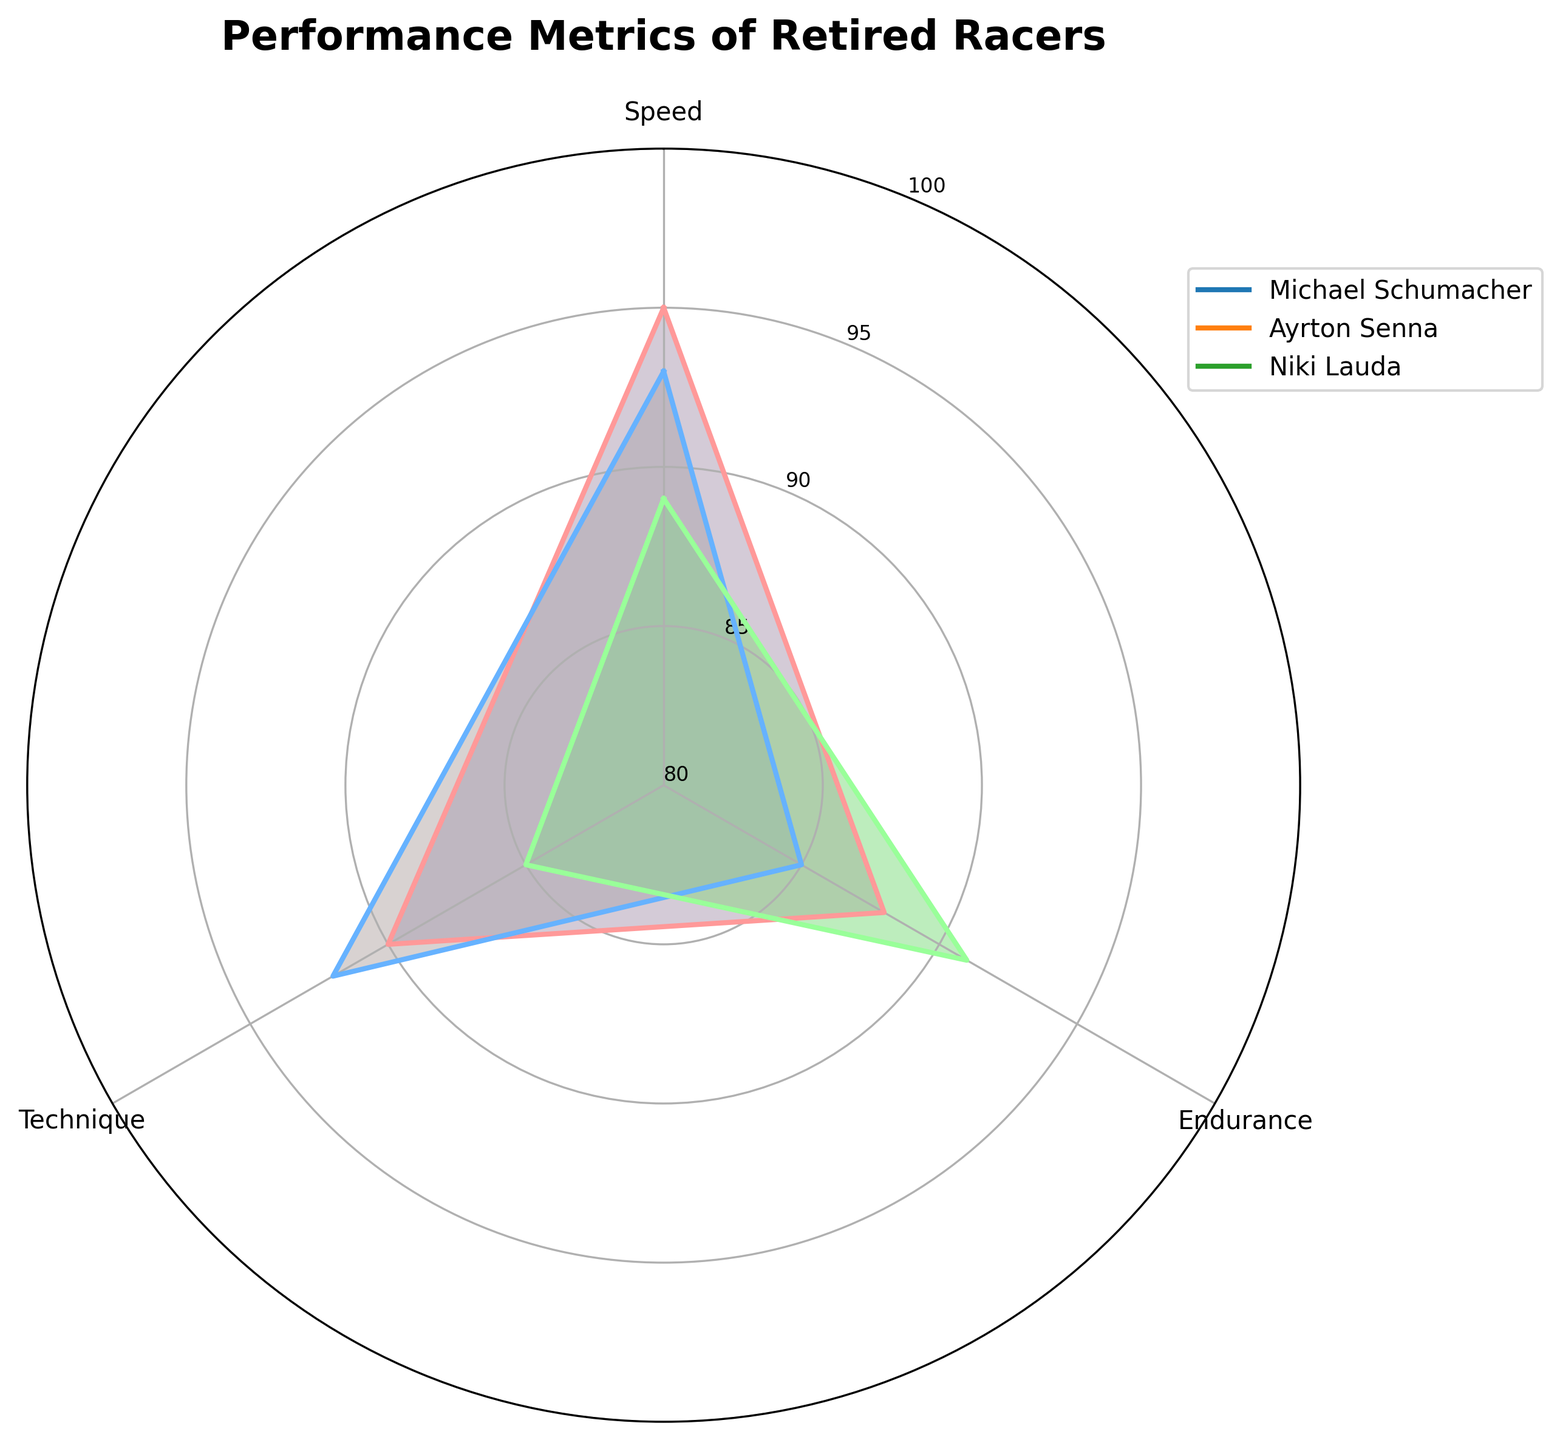What is the title of the figure? The title of the figure is displayed at the top. It provides a summary of what the figure represents. It states, "Performance Metrics of Retired Racers."
Answer: "Performance Metrics of Retired Racers" Which racer has the highest score in speed? By looking at the radar chart, identify the outermost point in the speed category for each racer. The racer with the point furthest from the center has the highest value. Michael Schumacher's point is the furthest in speed.
Answer: Michael Schumacher What is the average Technique score of all the racers? Sum up the Technique scores of all the racers (90 for Schumacher, 92 for Senna, and 85 for Lauda) and divide by the number of racers (3). (90 + 92 + 85) / 3 = 267 / 3 = 89
Answer: 89 Which metric has the largest variation between racers? Look at each metric’s span in the radar chart and find the one with the largest difference between the highest and lowest values. Endurance ranges from 85 (Senna) to 91 (Lauda), making the variation 6, which is the largest among the metrics.
Answer: Endurance Who has the lowest Endurance score? Check the inner points for Endurance on the radar chart and identify the racer who has the point closest to the center. Ayrton Senna has the lowest Endurance score with 85.
Answer: Ayrton Senna How do the Endurance scores of Michael Schumacher and Niki Lauda compare? Identify the Endurance scores from the chart for Schumacher (88) and Lauda (91). Schumacher's score is lower than Lauda's.
Answer: Schumacher's Endurance is lower than Lauda's Which racer has the most balanced performance across all metrics? A balanced performance would appear as an almost regular shape close to a circle. From the radar chart, Ayrton Senna's plot appears the most balanced across speed, endurance, and technique.
Answer: Ayrton Senna What is the total of Michael Schumacher's scores for all metrics? Sum up Schumacher's Speed (95), Endurance (88), and Technique (90). 95 + 88 + 90 = 273
Answer: 273 